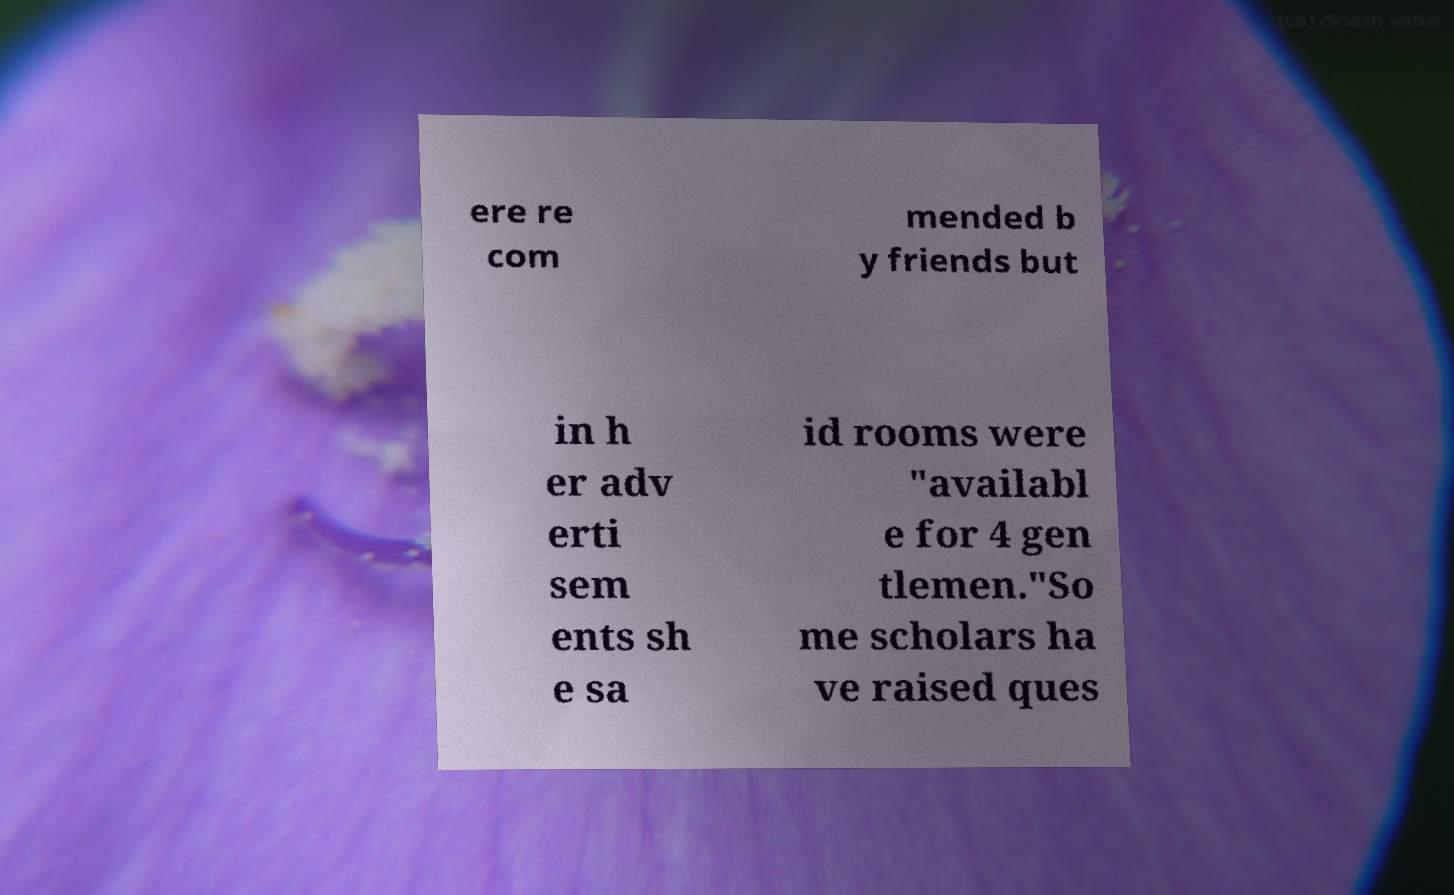I need the written content from this picture converted into text. Can you do that? ere re com mended b y friends but in h er adv erti sem ents sh e sa id rooms were "availabl e for 4 gen tlemen."So me scholars ha ve raised ques 